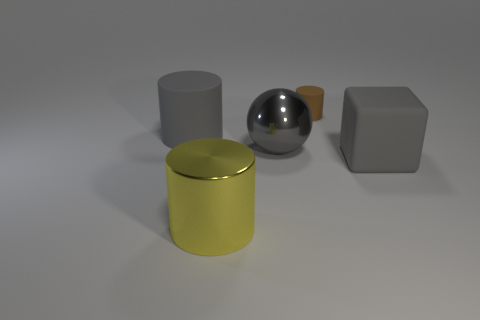Is there any other thing that is the same size as the brown matte cylinder?
Offer a very short reply. No. Is there a large rubber cylinder?
Offer a very short reply. Yes. There is a object behind the big gray object to the left of the metal thing that is in front of the gray block; what is its material?
Keep it short and to the point. Rubber. There is a yellow thing; is its shape the same as the big matte object that is on the left side of the small brown matte cylinder?
Your response must be concise. Yes. What number of metallic objects have the same shape as the small matte thing?
Make the answer very short. 1. What shape is the big yellow shiny thing?
Offer a very short reply. Cylinder. There is a cylinder that is in front of the large gray rubber thing on the left side of the gray metal sphere; what is its size?
Give a very brief answer. Large. How many things are either big gray cylinders or big yellow objects?
Offer a very short reply. 2. Is the shape of the yellow metallic thing the same as the brown object?
Your answer should be very brief. Yes. Is there a big ball that has the same material as the tiny brown object?
Keep it short and to the point. No. 